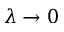<formula> <loc_0><loc_0><loc_500><loc_500>\lambda \to 0</formula> 